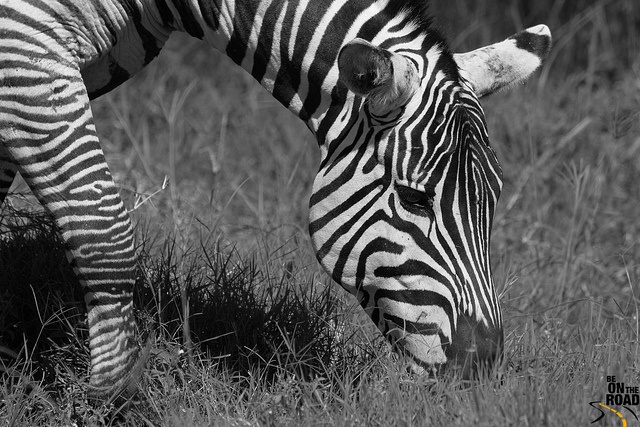Describe the objects in this image and their specific colors. I can see a zebra in gray, black, lightgray, and darkgray tones in this image. 